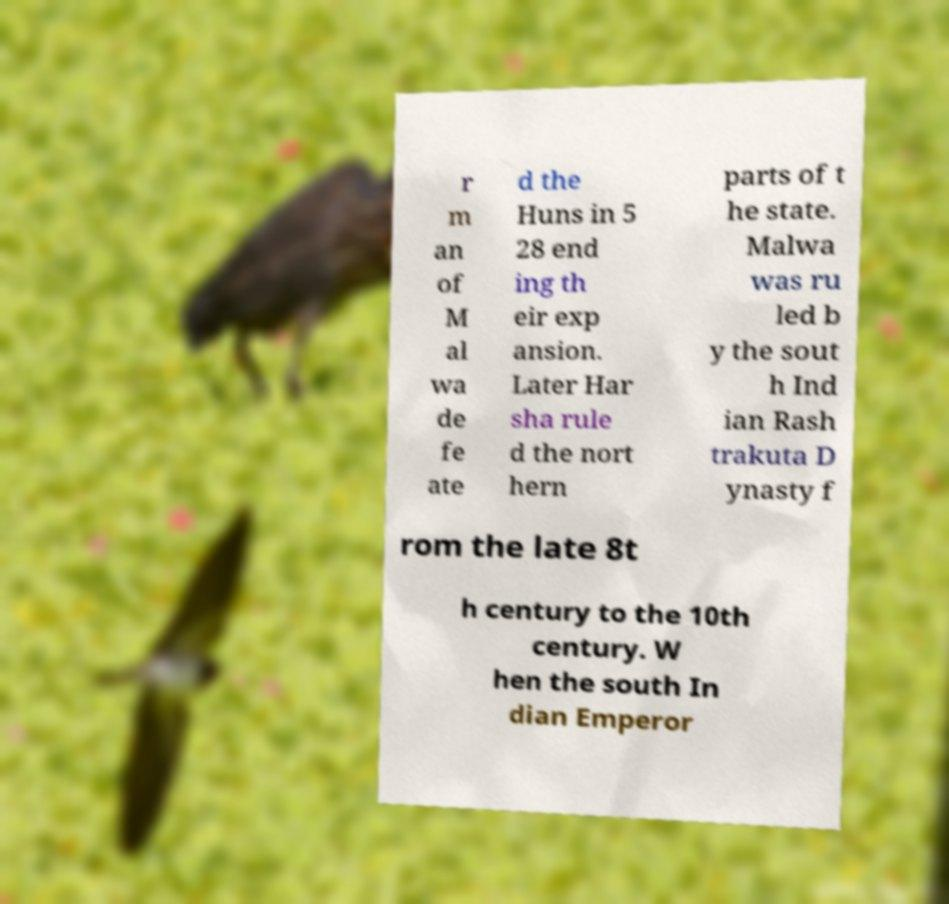What messages or text are displayed in this image? I need them in a readable, typed format. r m an of M al wa de fe ate d the Huns in 5 28 end ing th eir exp ansion. Later Har sha rule d the nort hern parts of t he state. Malwa was ru led b y the sout h Ind ian Rash trakuta D ynasty f rom the late 8t h century to the 10th century. W hen the south In dian Emperor 